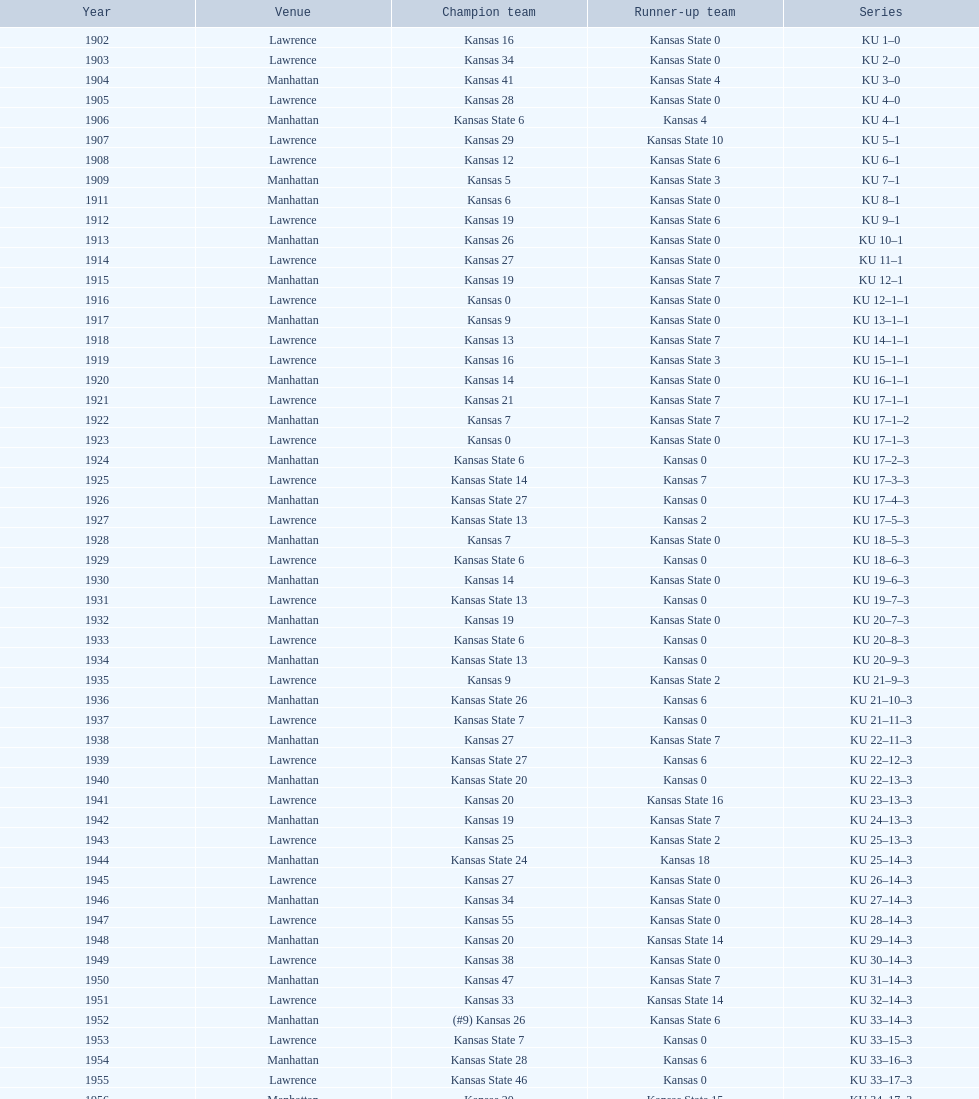How many times did kansas beat kansas state before 1910? 7. 